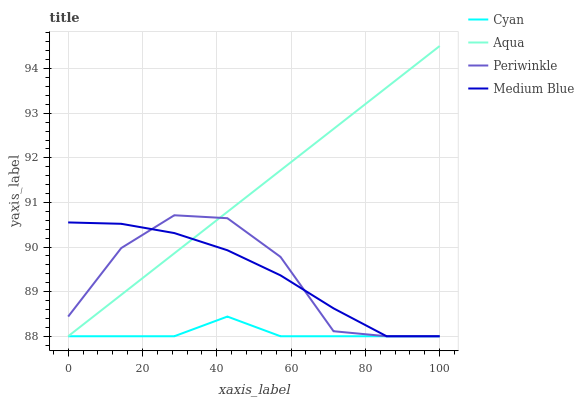Does Cyan have the minimum area under the curve?
Answer yes or no. Yes. Does Aqua have the maximum area under the curve?
Answer yes or no. Yes. Does Periwinkle have the minimum area under the curve?
Answer yes or no. No. Does Periwinkle have the maximum area under the curve?
Answer yes or no. No. Is Aqua the smoothest?
Answer yes or no. Yes. Is Periwinkle the roughest?
Answer yes or no. Yes. Is Periwinkle the smoothest?
Answer yes or no. No. Is Aqua the roughest?
Answer yes or no. No. Does Cyan have the lowest value?
Answer yes or no. Yes. Does Aqua have the highest value?
Answer yes or no. Yes. Does Periwinkle have the highest value?
Answer yes or no. No. Does Aqua intersect Medium Blue?
Answer yes or no. Yes. Is Aqua less than Medium Blue?
Answer yes or no. No. Is Aqua greater than Medium Blue?
Answer yes or no. No. 